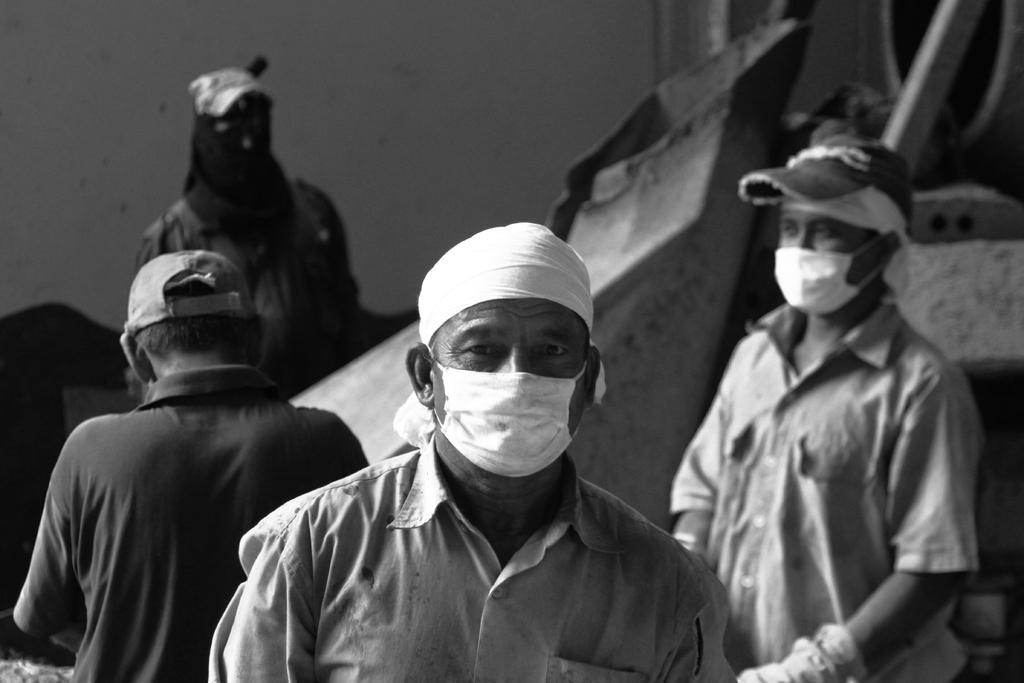How many people are in the image? There are four persons in the image. What are the persons wearing on their faces? The persons are wearing masks. What can be seen behind the persons? There is an object visible behind the persons. What is the background of the image made of? There is a wall visible behind the persons. How many rabbits can be seen playing in the field in the image? There are no rabbits or fields present in the image. 